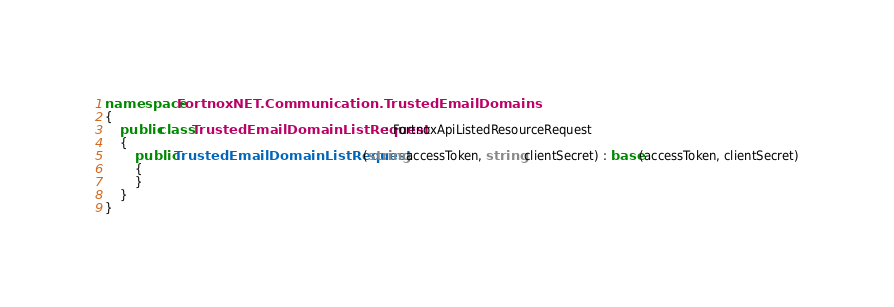<code> <loc_0><loc_0><loc_500><loc_500><_C#_>namespace FortnoxNET.Communication.TrustedEmailDomains
{
    public class TrustedEmailDomainListRequest : FortnoxApiListedResourceRequest
    {
        public TrustedEmailDomainListRequest(string accessToken, string clientSecret) : base(accessToken, clientSecret)
        {
        }
    }
}

</code> 